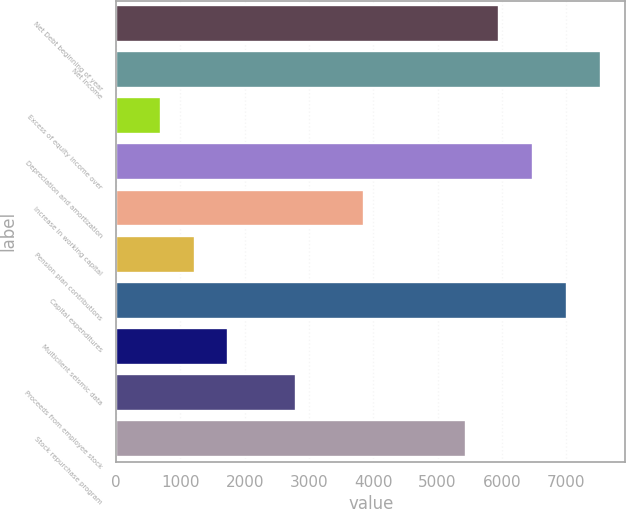Convert chart. <chart><loc_0><loc_0><loc_500><loc_500><bar_chart><fcel>Net Debt beginning of year<fcel>Net income<fcel>Excess of equity income over<fcel>Depreciation and amortization<fcel>Increase in working capital<fcel>Pension plan contributions<fcel>Capital expenditures<fcel>Multiclient seismic data<fcel>Proceeds from employee stock<fcel>Stock repurchase program<nl><fcel>5961.9<fcel>7542.6<fcel>692.9<fcel>6488.8<fcel>3854.3<fcel>1219.8<fcel>7015.7<fcel>1746.7<fcel>2800.5<fcel>5435<nl></chart> 